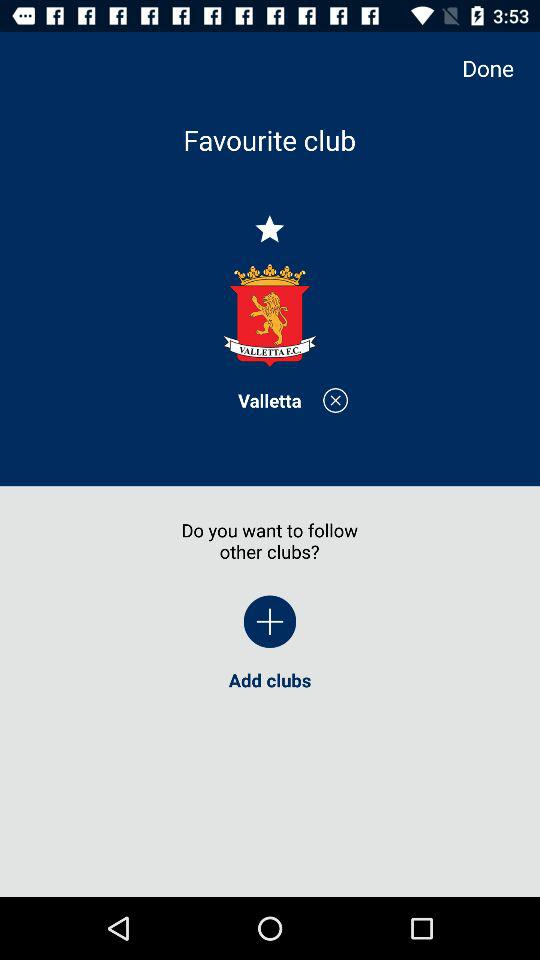What is the application name?
When the provided information is insufficient, respond with <no answer>. <no answer> 